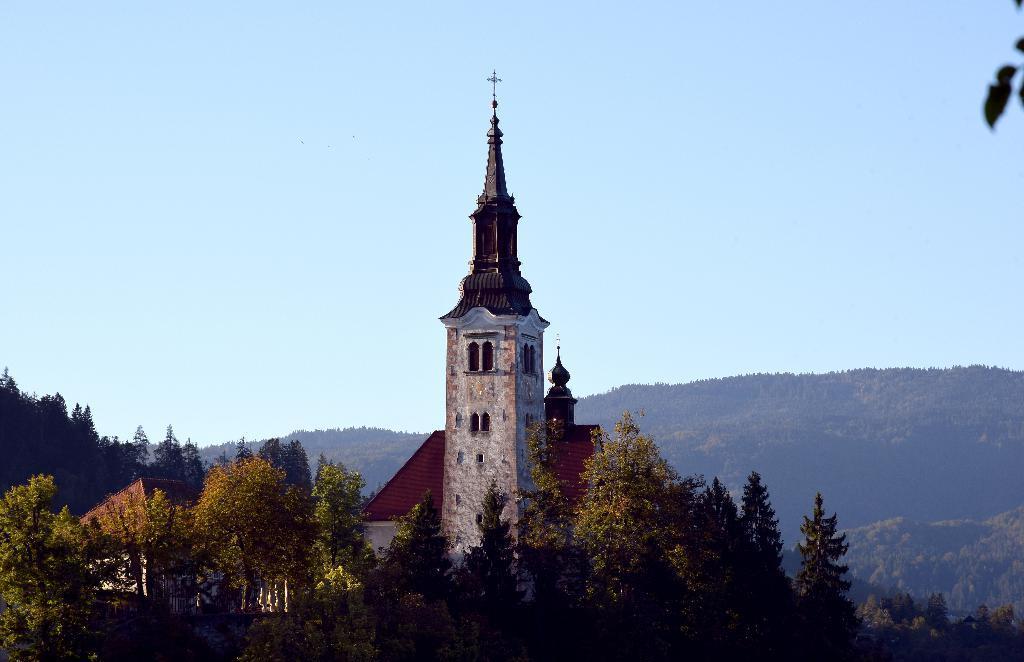Please provide a concise description of this image. In this picture we can see trees, buildings and in the background we can see the sky. 